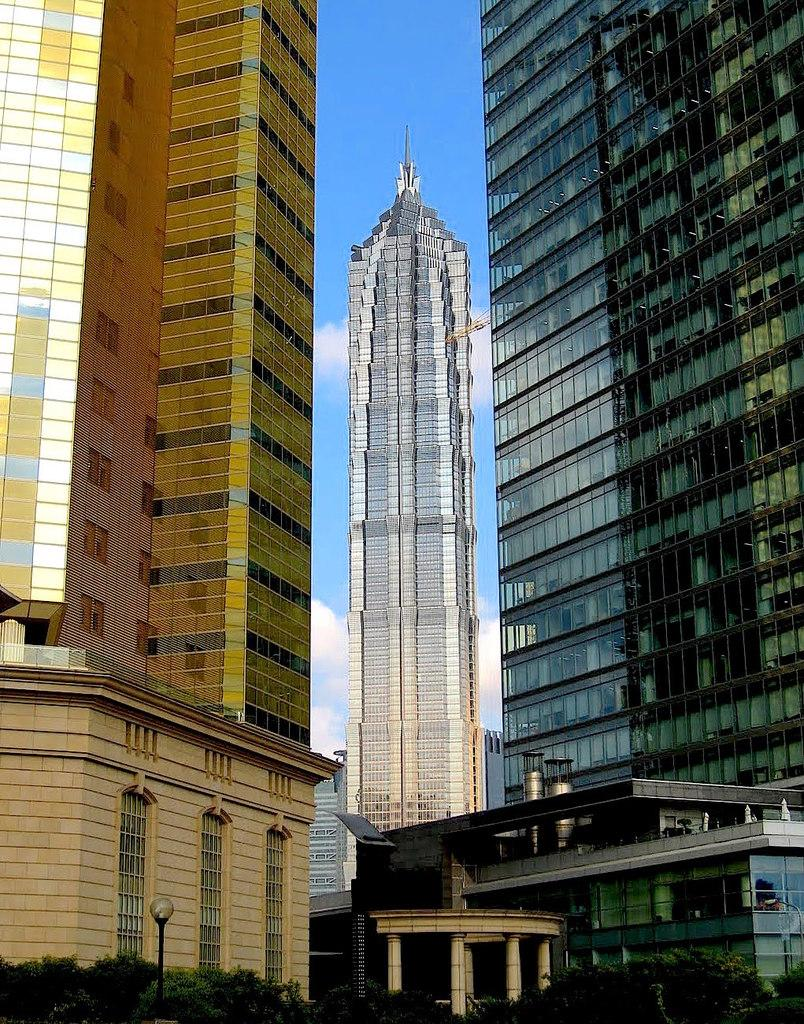What type of structures are present in the image? There are skyscrapers and buildings in the image. What can be seen in the background of the image? The sky is visible in the background of the image, and there are clouds present. What type of vegetation is visible at the bottom of the image? Trees are visible at the bottom of the image. What type of lighting fixture is present in the image? There is a street light in the image. What architectural feature can be seen in the image? There are pillars in the image. What type of vegetable is growing on the top of the skyscraper in the image? There are no vegetables growing on the top of the skyscraper in the image; it is a building with no vegetation present. 